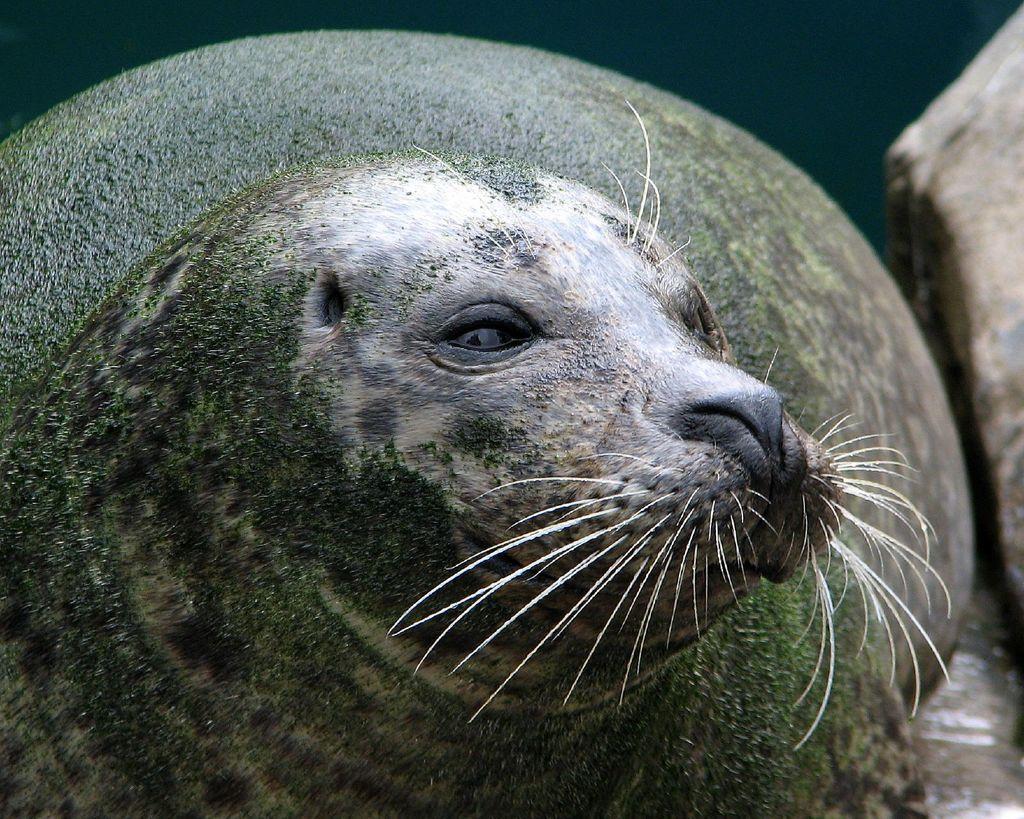Can you describe this image briefly? There is a seal with green color thing on the body. 